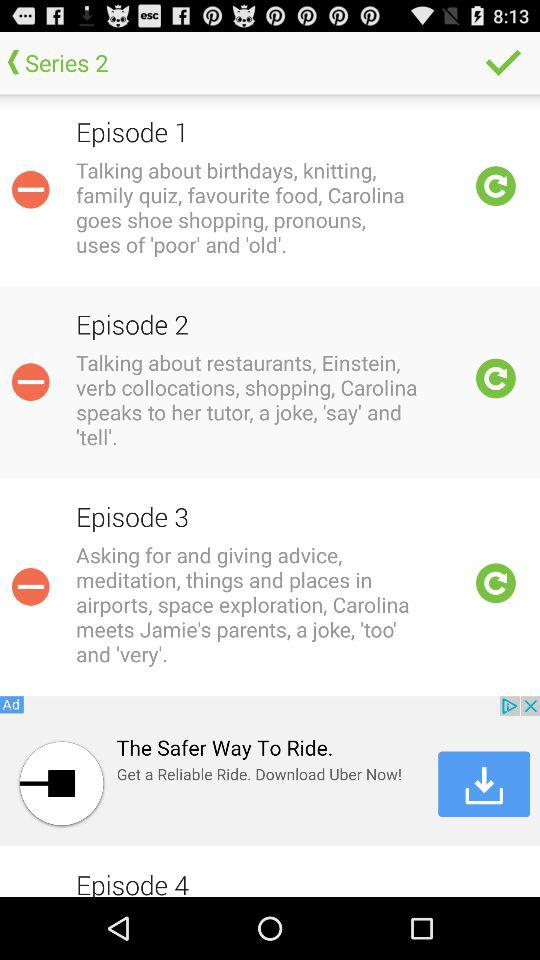How many episodes are there in series 2?
When the provided information is insufficient, respond with <no answer>. <no answer> 